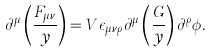Convert formula to latex. <formula><loc_0><loc_0><loc_500><loc_500>\partial ^ { \mu } \left ( \frac { F _ { \mu \nu } } { y } \right ) = V \epsilon _ { \mu \nu \rho } \partial ^ { \mu } \left ( \frac { G } { y } \right ) \partial ^ { \rho } \phi .</formula> 